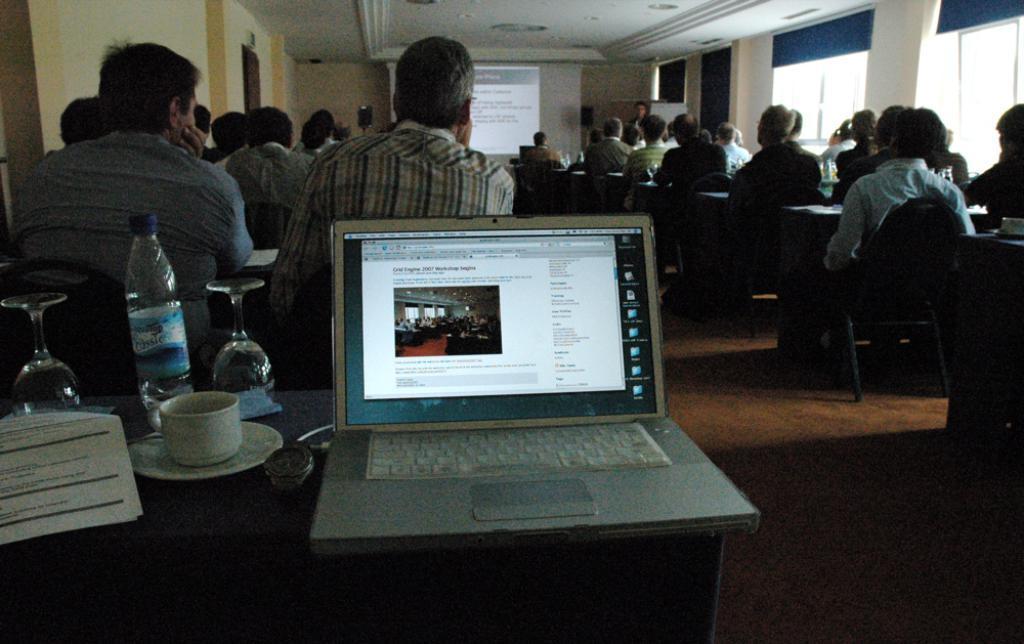In one or two sentences, can you explain what this image depicts? This image is taken indoors. At the bottom of the image there is a table with a laptop and a few things on it and there is a floor. In this image many people are sitting on the chairs and using the benches. In the background there are a few walls with windows, curtains and a door. There is a projector screen on the wall. At the top of the image there is a ceiling. 